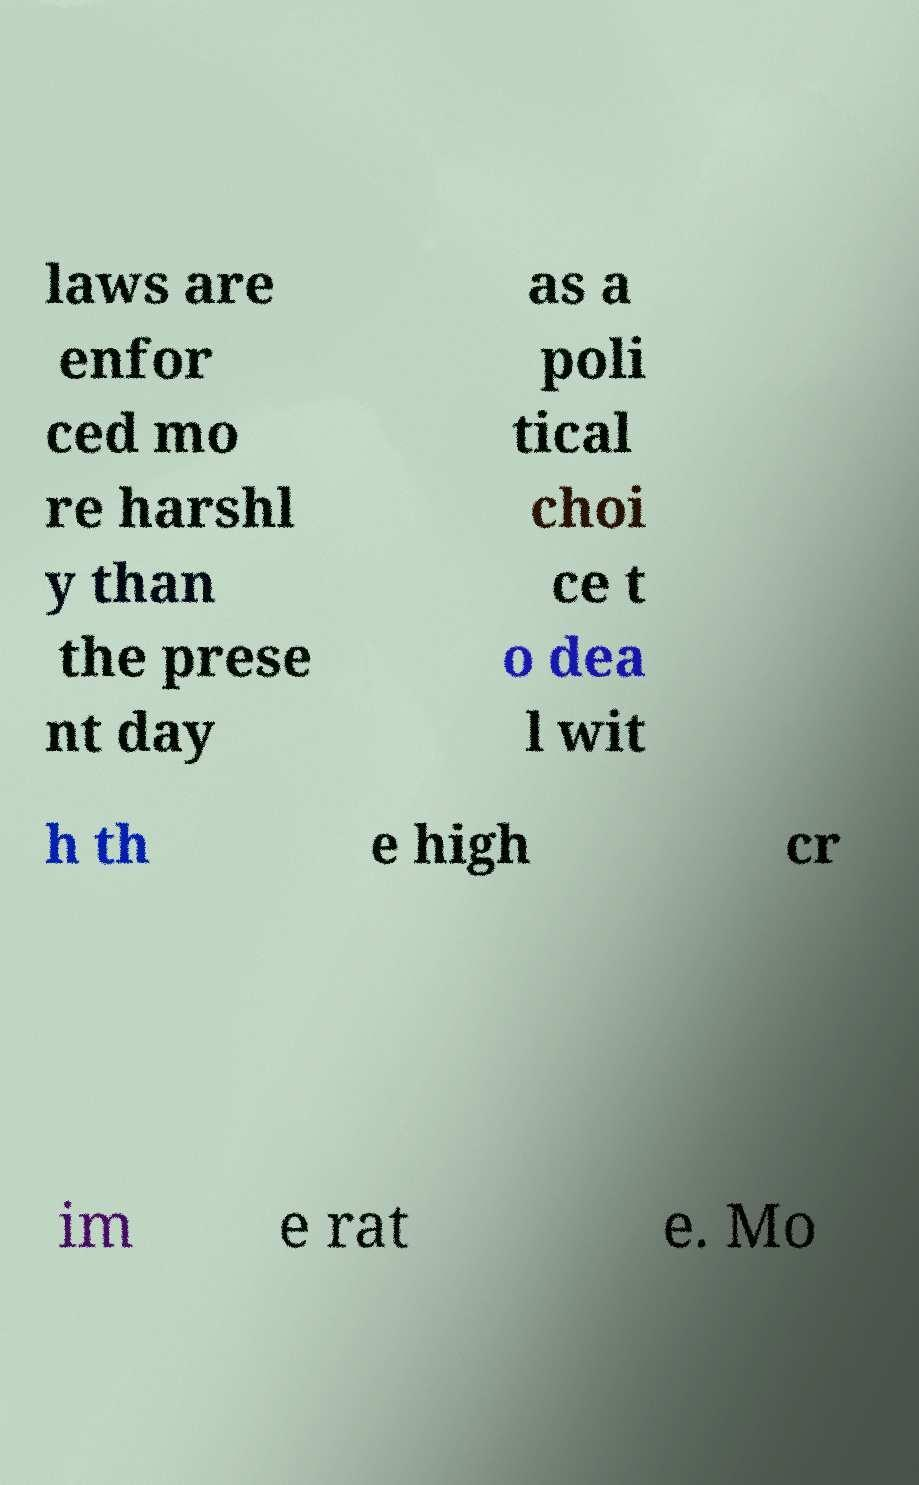I need the written content from this picture converted into text. Can you do that? laws are enfor ced mo re harshl y than the prese nt day as a poli tical choi ce t o dea l wit h th e high cr im e rat e. Mo 